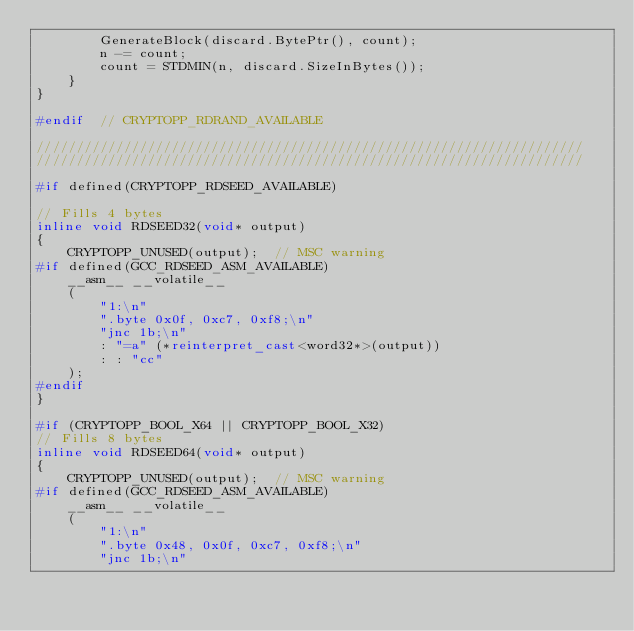<code> <loc_0><loc_0><loc_500><loc_500><_C++_>        GenerateBlock(discard.BytePtr(), count);
        n -= count;
        count = STDMIN(n, discard.SizeInBytes());
    }
}

#endif  // CRYPTOPP_RDRAND_AVAILABLE

/////////////////////////////////////////////////////////////////////
/////////////////////////////////////////////////////////////////////

#if defined(CRYPTOPP_RDSEED_AVAILABLE)

// Fills 4 bytes
inline void RDSEED32(void* output)
{
    CRYPTOPP_UNUSED(output);  // MSC warning
#if defined(GCC_RDSEED_ASM_AVAILABLE)
    __asm__ __volatile__
    (
        "1:\n"
        ".byte 0x0f, 0xc7, 0xf8;\n"
        "jnc 1b;\n"
        : "=a" (*reinterpret_cast<word32*>(output))
        : : "cc"
    );
#endif
}

#if (CRYPTOPP_BOOL_X64 || CRYPTOPP_BOOL_X32)
// Fills 8 bytes
inline void RDSEED64(void* output)
{
    CRYPTOPP_UNUSED(output);  // MSC warning
#if defined(GCC_RDSEED_ASM_AVAILABLE)
    __asm__ __volatile__
    (
        "1:\n"
        ".byte 0x48, 0x0f, 0xc7, 0xf8;\n"
        "jnc 1b;\n"</code> 